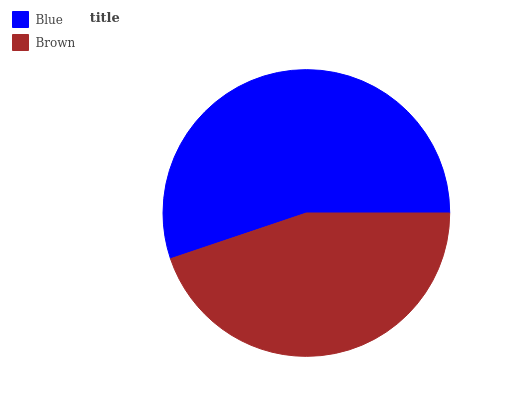Is Brown the minimum?
Answer yes or no. Yes. Is Blue the maximum?
Answer yes or no. Yes. Is Brown the maximum?
Answer yes or no. No. Is Blue greater than Brown?
Answer yes or no. Yes. Is Brown less than Blue?
Answer yes or no. Yes. Is Brown greater than Blue?
Answer yes or no. No. Is Blue less than Brown?
Answer yes or no. No. Is Blue the high median?
Answer yes or no. Yes. Is Brown the low median?
Answer yes or no. Yes. Is Brown the high median?
Answer yes or no. No. Is Blue the low median?
Answer yes or no. No. 